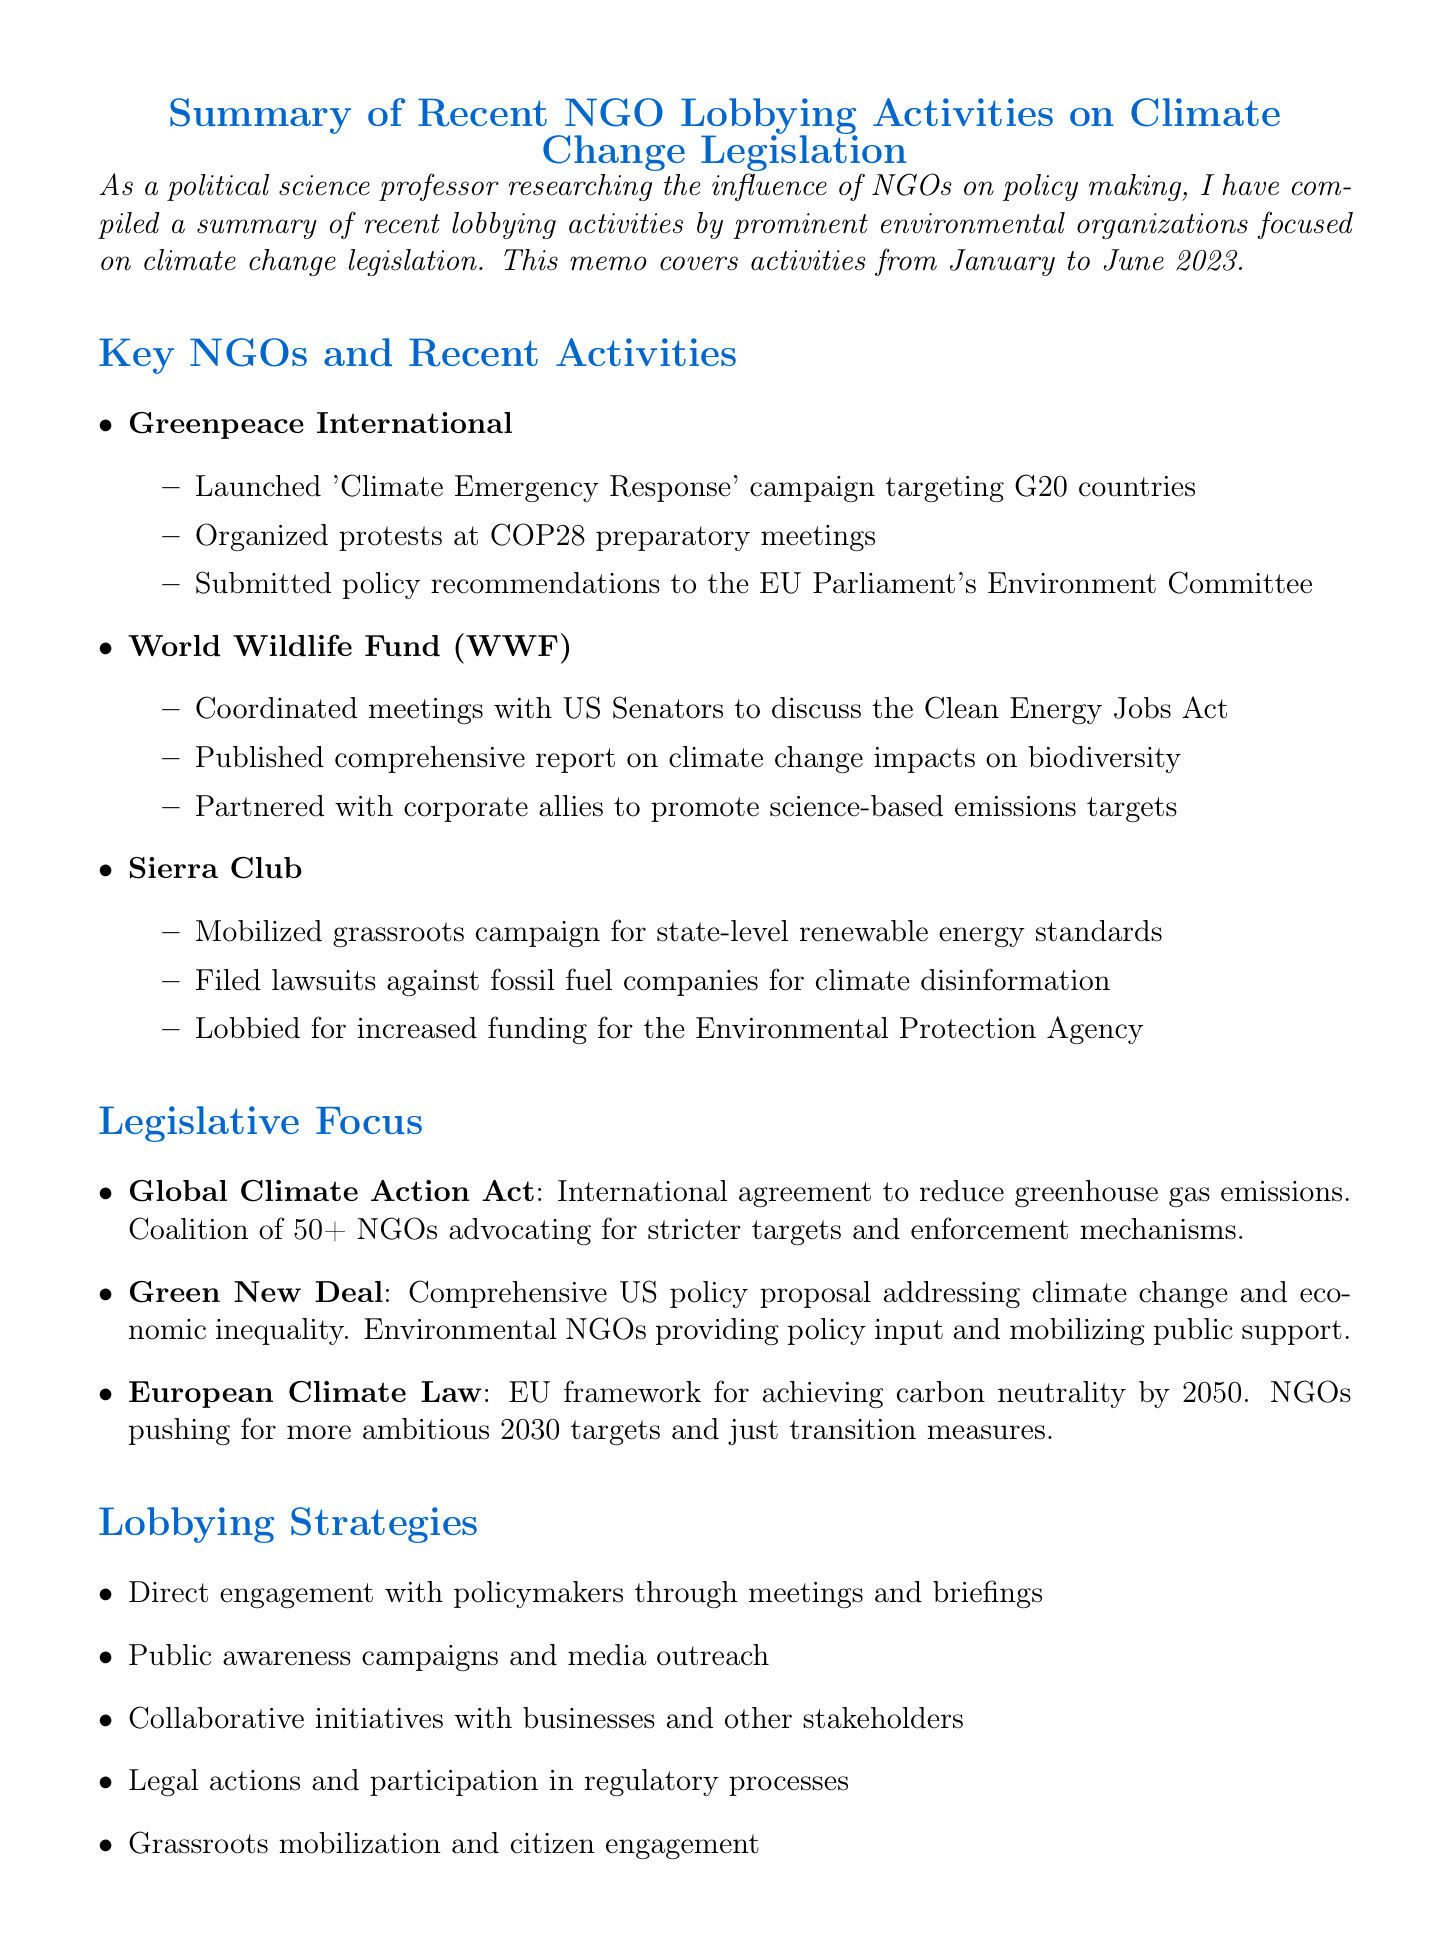What is the title of the memo? The title succinctly describes the subject of the document, which is about NGO lobbying activities related to climate change legislation.
Answer: Summary of Recent NGO Lobbying Activities on Climate Change Legislation What time frame does the memo cover? The memo specifies the period during which the activities were analyzed and summarized.
Answer: January to June 2023 Which organization launched the 'Climate Emergency Response' campaign? This information identifies the specific NGO responsible for the named campaign mentioned in the document.
Answer: Greenpeace International What is one of the lobbying strategies used by NGOs? This question prompts for a specific tactic NGOs use in their lobbying efforts as outlined in the document.
Answer: Direct engagement with policymakers through meetings and briefings How many NGOs are advocating for stricter targets under the Global Climate Action Act? This question retrieves a numerical piece of information regarding NGO involvement in this specific legislative focus.
Answer: 50+ What is a challenge faced by NGOs in climate change lobbying? This question seeks a specific difficulty outlined in the document that NGOs encounter in their advocacy efforts.
Answer: Opposition from fossil fuel industry lobbying groups What legislative focus is described as a comprehensive US policy proposal? This question refers to a specific policy initiative highlighted in the document that addresses both climate change and economic issues.
Answer: Green New Deal What conclusion is drawn about the role of NGOs? This question aims to summarize the overall assessment regarding NGOs' contributions to climate change legislation mentioned in the document.
Answer: NGOs continue to play a crucial role in shaping climate change legislation Which upcoming event presents an opportunity for NGO influence? This question seeks to identify a significant future event that allows NGOs to leverage their activities for climate policy changes.
Answer: COP28 conference 